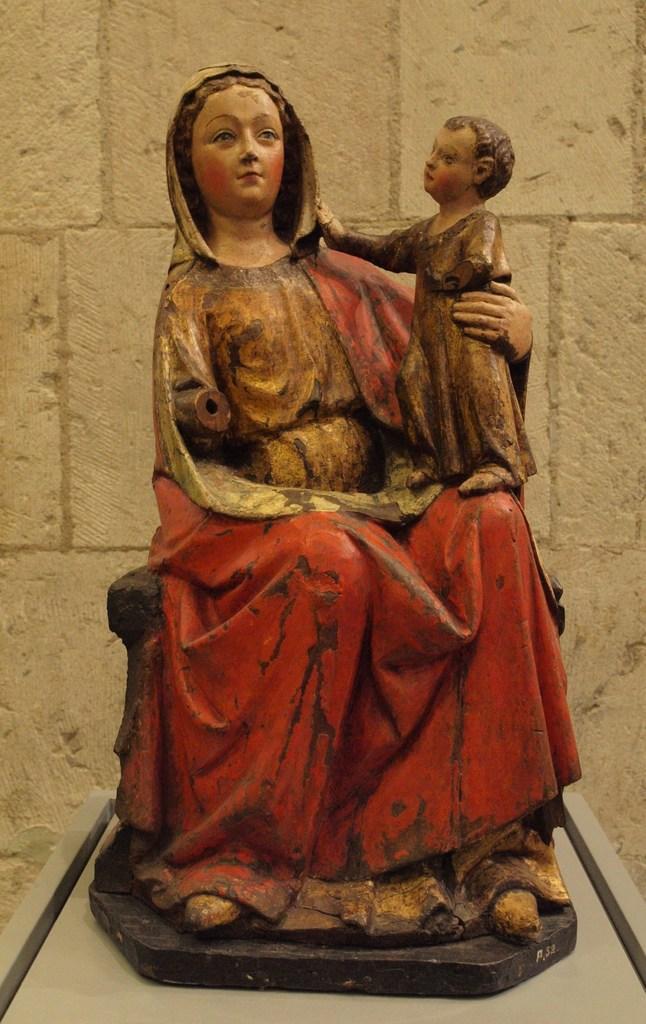Describe this image in one or two sentences. In this picture we can see the statue of a lady holding a baby in her hand and sitting on something. Behind the statue we can see a stone wall. 